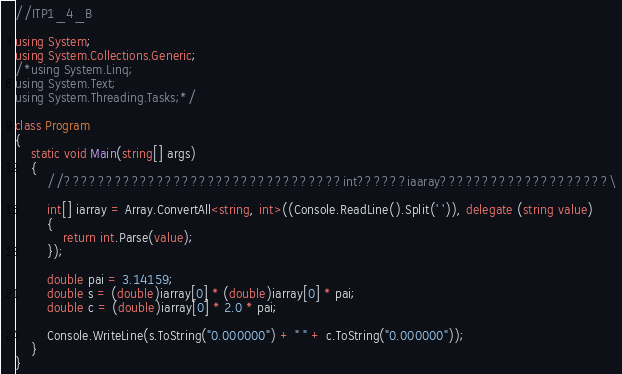<code> <loc_0><loc_0><loc_500><loc_500><_C#_>//ITP1_4_B

using System;
using System.Collections.Generic;
/*using System.Linq;
using System.Text;
using System.Threading.Tasks;*/

class Program
{
    static void Main(string[] args)
    {
        //?????????????????????????????????int??????iaaray????????????????????\

        int[] iarray = Array.ConvertAll<string, int>((Console.ReadLine().Split(' ')), delegate (string value)
        {
            return int.Parse(value);
        });

        double pai = 3.14159;
        double s = (double)iarray[0] * (double)iarray[0] * pai;
        double c = (double)iarray[0] * 2.0 * pai;

        Console.WriteLine(s.ToString("0.000000") + " " + c.ToString("0.000000"));
    }
}</code> 